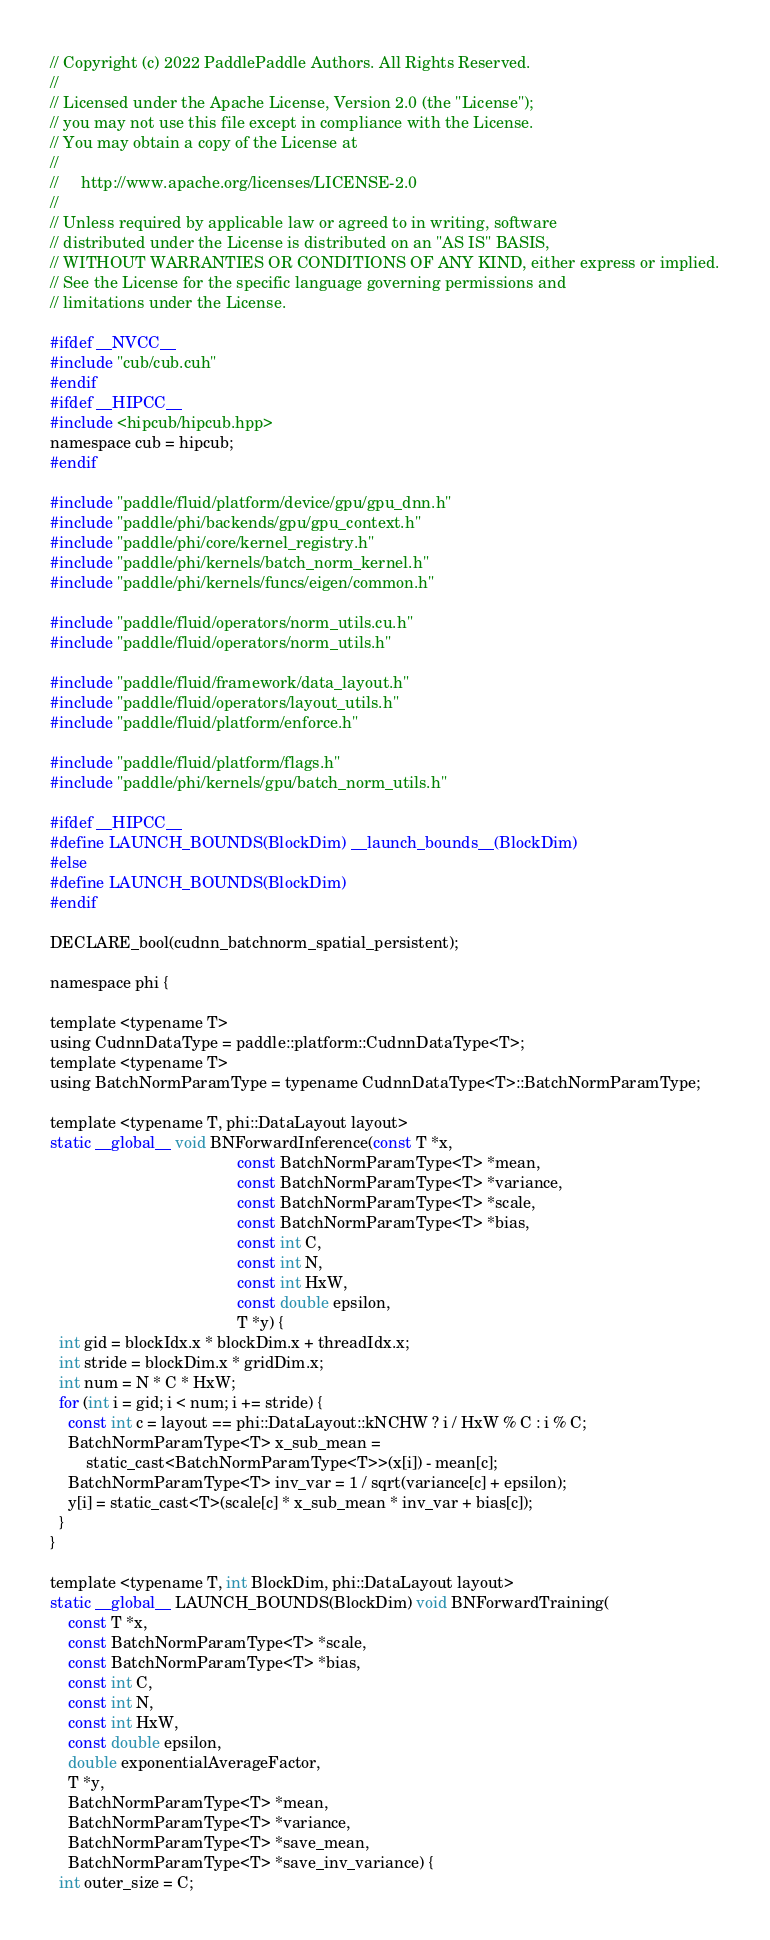Convert code to text. <code><loc_0><loc_0><loc_500><loc_500><_Cuda_>// Copyright (c) 2022 PaddlePaddle Authors. All Rights Reserved.
//
// Licensed under the Apache License, Version 2.0 (the "License");
// you may not use this file except in compliance with the License.
// You may obtain a copy of the License at
//
//     http://www.apache.org/licenses/LICENSE-2.0
//
// Unless required by applicable law or agreed to in writing, software
// distributed under the License is distributed on an "AS IS" BASIS,
// WITHOUT WARRANTIES OR CONDITIONS OF ANY KIND, either express or implied.
// See the License for the specific language governing permissions and
// limitations under the License.

#ifdef __NVCC__
#include "cub/cub.cuh"
#endif
#ifdef __HIPCC__
#include <hipcub/hipcub.hpp>
namespace cub = hipcub;
#endif

#include "paddle/fluid/platform/device/gpu/gpu_dnn.h"
#include "paddle/phi/backends/gpu/gpu_context.h"
#include "paddle/phi/core/kernel_registry.h"
#include "paddle/phi/kernels/batch_norm_kernel.h"
#include "paddle/phi/kernels/funcs/eigen/common.h"

#include "paddle/fluid/operators/norm_utils.cu.h"
#include "paddle/fluid/operators/norm_utils.h"

#include "paddle/fluid/framework/data_layout.h"
#include "paddle/fluid/operators/layout_utils.h"
#include "paddle/fluid/platform/enforce.h"

#include "paddle/fluid/platform/flags.h"
#include "paddle/phi/kernels/gpu/batch_norm_utils.h"

#ifdef __HIPCC__
#define LAUNCH_BOUNDS(BlockDim) __launch_bounds__(BlockDim)
#else
#define LAUNCH_BOUNDS(BlockDim)
#endif

DECLARE_bool(cudnn_batchnorm_spatial_persistent);

namespace phi {

template <typename T>
using CudnnDataType = paddle::platform::CudnnDataType<T>;
template <typename T>
using BatchNormParamType = typename CudnnDataType<T>::BatchNormParamType;

template <typename T, phi::DataLayout layout>
static __global__ void BNForwardInference(const T *x,
                                          const BatchNormParamType<T> *mean,
                                          const BatchNormParamType<T> *variance,
                                          const BatchNormParamType<T> *scale,
                                          const BatchNormParamType<T> *bias,
                                          const int C,
                                          const int N,
                                          const int HxW,
                                          const double epsilon,
                                          T *y) {
  int gid = blockIdx.x * blockDim.x + threadIdx.x;
  int stride = blockDim.x * gridDim.x;
  int num = N * C * HxW;
  for (int i = gid; i < num; i += stride) {
    const int c = layout == phi::DataLayout::kNCHW ? i / HxW % C : i % C;
    BatchNormParamType<T> x_sub_mean =
        static_cast<BatchNormParamType<T>>(x[i]) - mean[c];
    BatchNormParamType<T> inv_var = 1 / sqrt(variance[c] + epsilon);
    y[i] = static_cast<T>(scale[c] * x_sub_mean * inv_var + bias[c]);
  }
}

template <typename T, int BlockDim, phi::DataLayout layout>
static __global__ LAUNCH_BOUNDS(BlockDim) void BNForwardTraining(
    const T *x,
    const BatchNormParamType<T> *scale,
    const BatchNormParamType<T> *bias,
    const int C,
    const int N,
    const int HxW,
    const double epsilon,
    double exponentialAverageFactor,
    T *y,
    BatchNormParamType<T> *mean,
    BatchNormParamType<T> *variance,
    BatchNormParamType<T> *save_mean,
    BatchNormParamType<T> *save_inv_variance) {
  int outer_size = C;</code> 